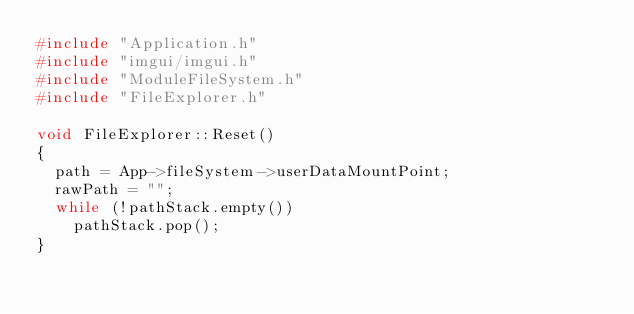<code> <loc_0><loc_0><loc_500><loc_500><_C++_>#include "Application.h"
#include "imgui/imgui.h"
#include "ModuleFileSystem.h"
#include "FileExplorer.h"

void FileExplorer::Reset()
{
	path = App->fileSystem->userDataMountPoint;
	rawPath = "";
	while (!pathStack.empty())
		pathStack.pop();
}
</code> 